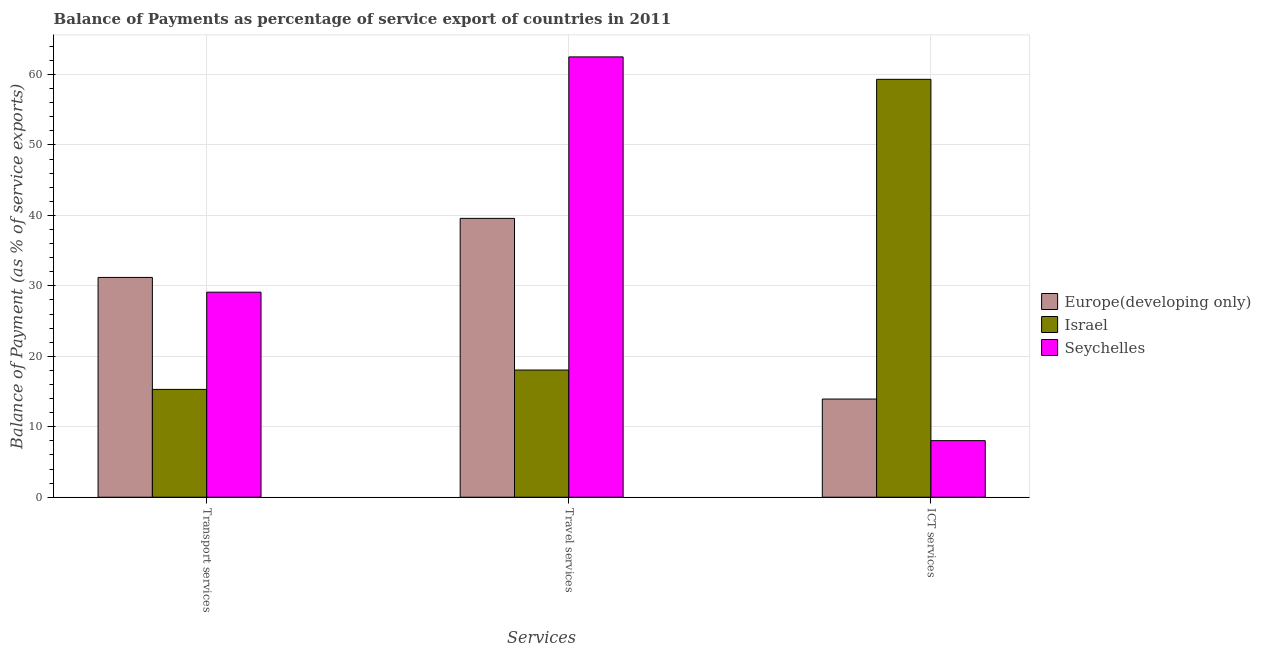How many different coloured bars are there?
Make the answer very short. 3. How many bars are there on the 2nd tick from the left?
Your response must be concise. 3. What is the label of the 3rd group of bars from the left?
Offer a terse response. ICT services. What is the balance of payment of travel services in Europe(developing only)?
Offer a very short reply. 39.58. Across all countries, what is the maximum balance of payment of travel services?
Offer a terse response. 62.51. Across all countries, what is the minimum balance of payment of travel services?
Give a very brief answer. 18.05. In which country was the balance of payment of travel services maximum?
Offer a terse response. Seychelles. In which country was the balance of payment of ict services minimum?
Give a very brief answer. Seychelles. What is the total balance of payment of transport services in the graph?
Offer a very short reply. 75.61. What is the difference between the balance of payment of travel services in Seychelles and that in Israel?
Ensure brevity in your answer.  44.45. What is the difference between the balance of payment of ict services in Europe(developing only) and the balance of payment of transport services in Seychelles?
Your answer should be very brief. -15.17. What is the average balance of payment of travel services per country?
Your answer should be very brief. 40.05. What is the difference between the balance of payment of ict services and balance of payment of travel services in Seychelles?
Your answer should be compact. -54.48. What is the ratio of the balance of payment of transport services in Israel to that in Seychelles?
Your answer should be compact. 0.53. What is the difference between the highest and the second highest balance of payment of ict services?
Your answer should be very brief. 45.39. What is the difference between the highest and the lowest balance of payment of ict services?
Provide a short and direct response. 51.29. In how many countries, is the balance of payment of transport services greater than the average balance of payment of transport services taken over all countries?
Your response must be concise. 2. Is the sum of the balance of payment of transport services in Israel and Europe(developing only) greater than the maximum balance of payment of ict services across all countries?
Offer a very short reply. No. What does the 3rd bar from the right in ICT services represents?
Give a very brief answer. Europe(developing only). Is it the case that in every country, the sum of the balance of payment of transport services and balance of payment of travel services is greater than the balance of payment of ict services?
Provide a succinct answer. No. What is the difference between two consecutive major ticks on the Y-axis?
Offer a very short reply. 10. Does the graph contain any zero values?
Offer a very short reply. No. Does the graph contain grids?
Offer a very short reply. Yes. Where does the legend appear in the graph?
Your answer should be compact. Center right. What is the title of the graph?
Offer a very short reply. Balance of Payments as percentage of service export of countries in 2011. Does "Virgin Islands" appear as one of the legend labels in the graph?
Your answer should be compact. No. What is the label or title of the X-axis?
Your answer should be very brief. Services. What is the label or title of the Y-axis?
Make the answer very short. Balance of Payment (as % of service exports). What is the Balance of Payment (as % of service exports) of Europe(developing only) in Transport services?
Make the answer very short. 31.2. What is the Balance of Payment (as % of service exports) of Israel in Transport services?
Offer a terse response. 15.31. What is the Balance of Payment (as % of service exports) of Seychelles in Transport services?
Offer a very short reply. 29.11. What is the Balance of Payment (as % of service exports) of Europe(developing only) in Travel services?
Provide a succinct answer. 39.58. What is the Balance of Payment (as % of service exports) of Israel in Travel services?
Offer a very short reply. 18.05. What is the Balance of Payment (as % of service exports) in Seychelles in Travel services?
Keep it short and to the point. 62.51. What is the Balance of Payment (as % of service exports) in Europe(developing only) in ICT services?
Keep it short and to the point. 13.94. What is the Balance of Payment (as % of service exports) in Israel in ICT services?
Provide a short and direct response. 59.32. What is the Balance of Payment (as % of service exports) in Seychelles in ICT services?
Your response must be concise. 8.03. Across all Services, what is the maximum Balance of Payment (as % of service exports) of Europe(developing only)?
Give a very brief answer. 39.58. Across all Services, what is the maximum Balance of Payment (as % of service exports) of Israel?
Ensure brevity in your answer.  59.32. Across all Services, what is the maximum Balance of Payment (as % of service exports) of Seychelles?
Your response must be concise. 62.51. Across all Services, what is the minimum Balance of Payment (as % of service exports) of Europe(developing only)?
Offer a very short reply. 13.94. Across all Services, what is the minimum Balance of Payment (as % of service exports) of Israel?
Offer a very short reply. 15.31. Across all Services, what is the minimum Balance of Payment (as % of service exports) in Seychelles?
Give a very brief answer. 8.03. What is the total Balance of Payment (as % of service exports) in Europe(developing only) in the graph?
Keep it short and to the point. 84.72. What is the total Balance of Payment (as % of service exports) in Israel in the graph?
Give a very brief answer. 92.68. What is the total Balance of Payment (as % of service exports) in Seychelles in the graph?
Offer a very short reply. 99.64. What is the difference between the Balance of Payment (as % of service exports) in Europe(developing only) in Transport services and that in Travel services?
Provide a short and direct response. -8.38. What is the difference between the Balance of Payment (as % of service exports) in Israel in Transport services and that in Travel services?
Offer a very short reply. -2.75. What is the difference between the Balance of Payment (as % of service exports) of Seychelles in Transport services and that in Travel services?
Ensure brevity in your answer.  -33.4. What is the difference between the Balance of Payment (as % of service exports) in Europe(developing only) in Transport services and that in ICT services?
Offer a very short reply. 17.26. What is the difference between the Balance of Payment (as % of service exports) of Israel in Transport services and that in ICT services?
Provide a short and direct response. -44.02. What is the difference between the Balance of Payment (as % of service exports) in Seychelles in Transport services and that in ICT services?
Offer a very short reply. 21.07. What is the difference between the Balance of Payment (as % of service exports) in Europe(developing only) in Travel services and that in ICT services?
Your response must be concise. 25.64. What is the difference between the Balance of Payment (as % of service exports) of Israel in Travel services and that in ICT services?
Provide a succinct answer. -41.27. What is the difference between the Balance of Payment (as % of service exports) in Seychelles in Travel services and that in ICT services?
Your response must be concise. 54.48. What is the difference between the Balance of Payment (as % of service exports) of Europe(developing only) in Transport services and the Balance of Payment (as % of service exports) of Israel in Travel services?
Your answer should be compact. 13.15. What is the difference between the Balance of Payment (as % of service exports) in Europe(developing only) in Transport services and the Balance of Payment (as % of service exports) in Seychelles in Travel services?
Offer a terse response. -31.31. What is the difference between the Balance of Payment (as % of service exports) in Israel in Transport services and the Balance of Payment (as % of service exports) in Seychelles in Travel services?
Your response must be concise. -47.2. What is the difference between the Balance of Payment (as % of service exports) in Europe(developing only) in Transport services and the Balance of Payment (as % of service exports) in Israel in ICT services?
Provide a succinct answer. -28.12. What is the difference between the Balance of Payment (as % of service exports) in Europe(developing only) in Transport services and the Balance of Payment (as % of service exports) in Seychelles in ICT services?
Offer a terse response. 23.17. What is the difference between the Balance of Payment (as % of service exports) in Israel in Transport services and the Balance of Payment (as % of service exports) in Seychelles in ICT services?
Keep it short and to the point. 7.28. What is the difference between the Balance of Payment (as % of service exports) in Europe(developing only) in Travel services and the Balance of Payment (as % of service exports) in Israel in ICT services?
Provide a succinct answer. -19.74. What is the difference between the Balance of Payment (as % of service exports) in Europe(developing only) in Travel services and the Balance of Payment (as % of service exports) in Seychelles in ICT services?
Give a very brief answer. 31.55. What is the difference between the Balance of Payment (as % of service exports) in Israel in Travel services and the Balance of Payment (as % of service exports) in Seychelles in ICT services?
Your response must be concise. 10.02. What is the average Balance of Payment (as % of service exports) of Europe(developing only) per Services?
Offer a very short reply. 28.24. What is the average Balance of Payment (as % of service exports) of Israel per Services?
Give a very brief answer. 30.89. What is the average Balance of Payment (as % of service exports) in Seychelles per Services?
Your answer should be very brief. 33.21. What is the difference between the Balance of Payment (as % of service exports) of Europe(developing only) and Balance of Payment (as % of service exports) of Israel in Transport services?
Offer a very short reply. 15.89. What is the difference between the Balance of Payment (as % of service exports) of Europe(developing only) and Balance of Payment (as % of service exports) of Seychelles in Transport services?
Provide a short and direct response. 2.09. What is the difference between the Balance of Payment (as % of service exports) of Israel and Balance of Payment (as % of service exports) of Seychelles in Transport services?
Offer a very short reply. -13.8. What is the difference between the Balance of Payment (as % of service exports) in Europe(developing only) and Balance of Payment (as % of service exports) in Israel in Travel services?
Provide a succinct answer. 21.53. What is the difference between the Balance of Payment (as % of service exports) of Europe(developing only) and Balance of Payment (as % of service exports) of Seychelles in Travel services?
Your answer should be very brief. -22.92. What is the difference between the Balance of Payment (as % of service exports) in Israel and Balance of Payment (as % of service exports) in Seychelles in Travel services?
Provide a short and direct response. -44.45. What is the difference between the Balance of Payment (as % of service exports) in Europe(developing only) and Balance of Payment (as % of service exports) in Israel in ICT services?
Your answer should be very brief. -45.39. What is the difference between the Balance of Payment (as % of service exports) of Europe(developing only) and Balance of Payment (as % of service exports) of Seychelles in ICT services?
Ensure brevity in your answer.  5.91. What is the difference between the Balance of Payment (as % of service exports) of Israel and Balance of Payment (as % of service exports) of Seychelles in ICT services?
Your response must be concise. 51.29. What is the ratio of the Balance of Payment (as % of service exports) in Europe(developing only) in Transport services to that in Travel services?
Provide a succinct answer. 0.79. What is the ratio of the Balance of Payment (as % of service exports) in Israel in Transport services to that in Travel services?
Offer a very short reply. 0.85. What is the ratio of the Balance of Payment (as % of service exports) in Seychelles in Transport services to that in Travel services?
Ensure brevity in your answer.  0.47. What is the ratio of the Balance of Payment (as % of service exports) in Europe(developing only) in Transport services to that in ICT services?
Your answer should be compact. 2.24. What is the ratio of the Balance of Payment (as % of service exports) in Israel in Transport services to that in ICT services?
Offer a very short reply. 0.26. What is the ratio of the Balance of Payment (as % of service exports) in Seychelles in Transport services to that in ICT services?
Provide a succinct answer. 3.62. What is the ratio of the Balance of Payment (as % of service exports) in Europe(developing only) in Travel services to that in ICT services?
Provide a succinct answer. 2.84. What is the ratio of the Balance of Payment (as % of service exports) in Israel in Travel services to that in ICT services?
Your answer should be very brief. 0.3. What is the ratio of the Balance of Payment (as % of service exports) of Seychelles in Travel services to that in ICT services?
Keep it short and to the point. 7.78. What is the difference between the highest and the second highest Balance of Payment (as % of service exports) of Europe(developing only)?
Make the answer very short. 8.38. What is the difference between the highest and the second highest Balance of Payment (as % of service exports) of Israel?
Keep it short and to the point. 41.27. What is the difference between the highest and the second highest Balance of Payment (as % of service exports) in Seychelles?
Make the answer very short. 33.4. What is the difference between the highest and the lowest Balance of Payment (as % of service exports) of Europe(developing only)?
Offer a terse response. 25.64. What is the difference between the highest and the lowest Balance of Payment (as % of service exports) in Israel?
Your answer should be compact. 44.02. What is the difference between the highest and the lowest Balance of Payment (as % of service exports) of Seychelles?
Provide a succinct answer. 54.48. 